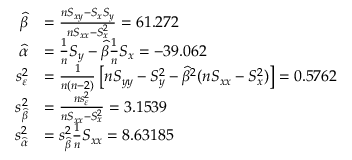Convert formula to latex. <formula><loc_0><loc_0><loc_500><loc_500>{ \begin{array} { r l } { { \widehat { \beta } } } & { = { \frac { n S _ { x y } - S _ { x } S _ { y } } { n S _ { x x } - S _ { x } ^ { 2 } } } = 6 1 . 2 7 2 } \\ { { \widehat { \alpha } } } & { = { \frac { 1 } { n } } S _ { y } - { \widehat { \beta } } { \frac { 1 } { n } } S _ { x } = - 3 9 . 0 6 2 } \\ { s _ { \varepsilon } ^ { 2 } } & { = { \frac { 1 } { n ( n - 2 ) } } \left [ n S _ { y y } - S _ { y } ^ { 2 } - { \widehat { \beta } } ^ { 2 } ( n S _ { x x } - S _ { x } ^ { 2 } ) \right ] = 0 . 5 7 6 2 } \\ { s _ { \widehat { \beta } } ^ { 2 } } & { = { \frac { n s _ { \varepsilon } ^ { 2 } } { n S _ { x x } - S _ { x } ^ { 2 } } } = 3 . 1 5 3 9 } \\ { s _ { \widehat { \alpha } } ^ { 2 } } & { = s _ { \widehat { \beta } } ^ { 2 } { \frac { 1 } { n } } S _ { x x } = 8 . 6 3 1 8 5 } \end{array} }</formula> 